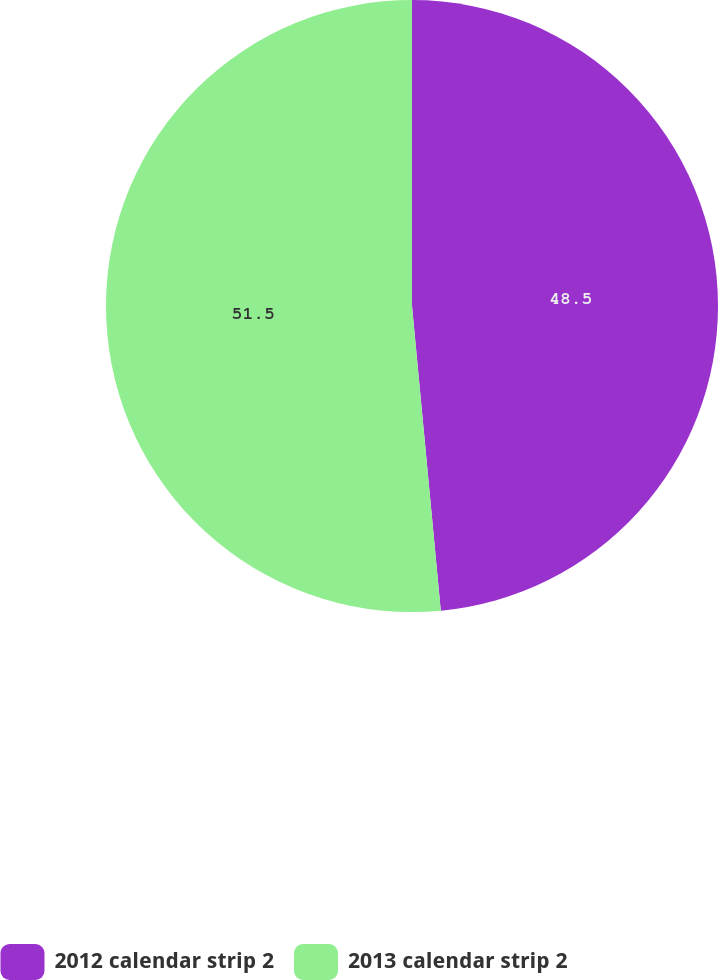Convert chart to OTSL. <chart><loc_0><loc_0><loc_500><loc_500><pie_chart><fcel>2012 calendar strip 2<fcel>2013 calendar strip 2<nl><fcel>48.5%<fcel>51.5%<nl></chart> 